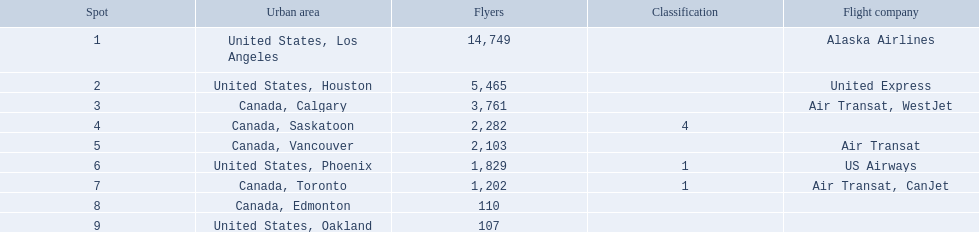Which cities had less than 2,000 passengers? United States, Phoenix, Canada, Toronto, Canada, Edmonton, United States, Oakland. Of these cities, which had fewer than 1,000 passengers? Canada, Edmonton, United States, Oakland. Of the cities in the previous answer, which one had only 107 passengers? United States, Oakland. 